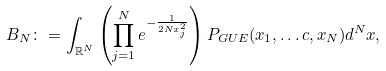Convert formula to latex. <formula><loc_0><loc_0><loc_500><loc_500>B _ { N } \colon = \int _ { \mathbb { R } ^ { N } } \left ( \prod _ { j = 1 } ^ { N } e ^ { - \frac { 1 } { 2 N x _ { j } ^ { 2 } } } \right ) P _ { G U E } ( x _ { 1 } , \dots c , x _ { N } ) d ^ { N } x ,</formula> 